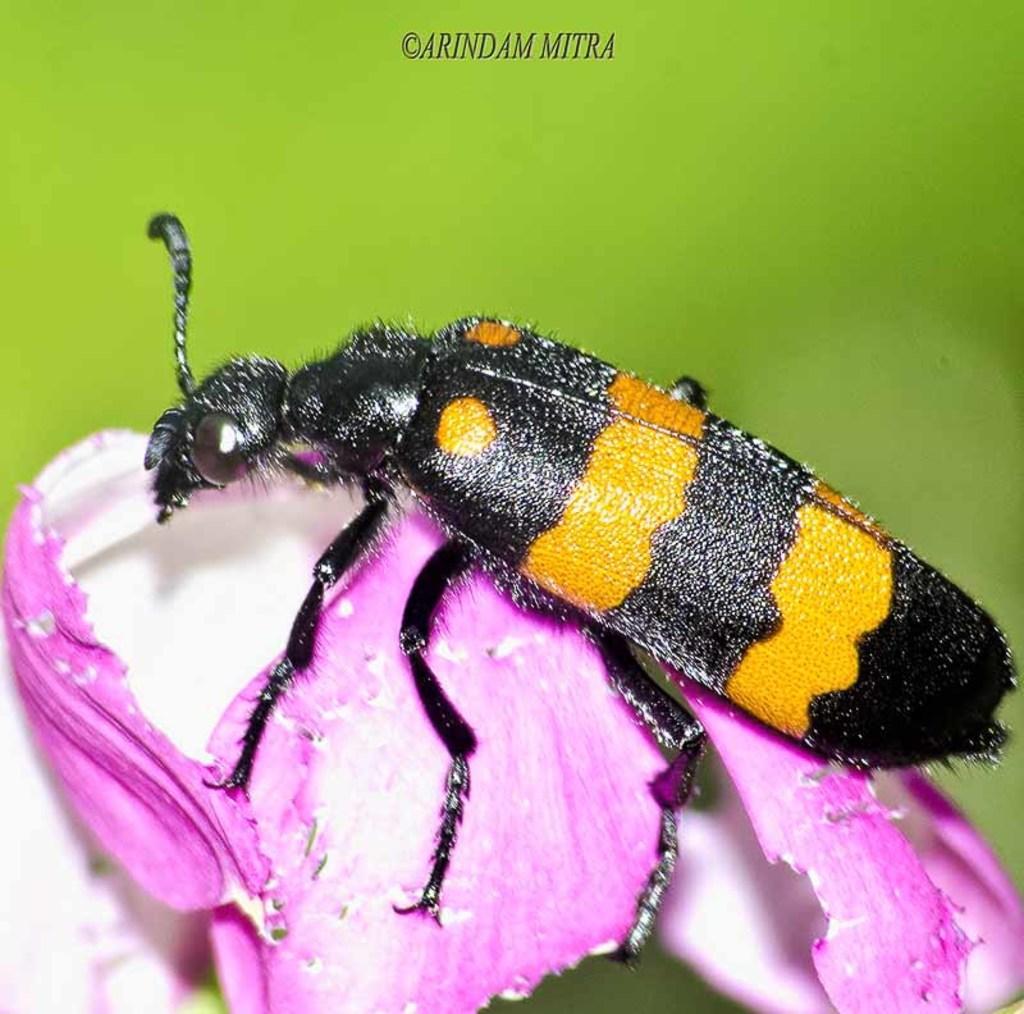Can you describe this image briefly? In this image we can see there is an insect on the flower. 